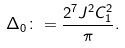<formula> <loc_0><loc_0><loc_500><loc_500>\Delta _ { 0 } \colon = \frac { 2 ^ { 7 } J ^ { 2 } C _ { 1 } ^ { 2 } } { \pi } .</formula> 